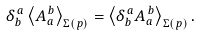<formula> <loc_0><loc_0><loc_500><loc_500>\delta ^ { \, a } _ { b } \left \langle A _ { a } ^ { \, b } \right \rangle _ { \Sigma ( p ) } = \left \langle \delta ^ { \, a } _ { b } A _ { a } ^ { \, b } \right \rangle _ { \Sigma ( p ) } .</formula> 